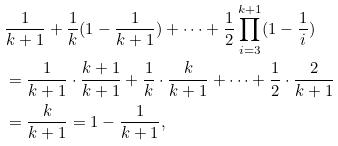Convert formula to latex. <formula><loc_0><loc_0><loc_500><loc_500>& \frac { 1 } { k + 1 } + \frac { 1 } { k } ( 1 - \frac { 1 } { k + 1 } ) + \dots + \frac { 1 } { 2 } \prod _ { i = 3 } ^ { k + 1 } ( 1 - \frac { 1 } { i } ) \\ & = \frac { 1 } { k + 1 } \cdot \frac { k + 1 } { k + 1 } + \frac { 1 } { k } \cdot \frac { k } { k + 1 } + \dots + \frac { 1 } { 2 } \cdot \frac { 2 } { k + 1 } \\ & = \frac { k } { k + 1 } = 1 - \frac { 1 } { k + 1 } ,</formula> 